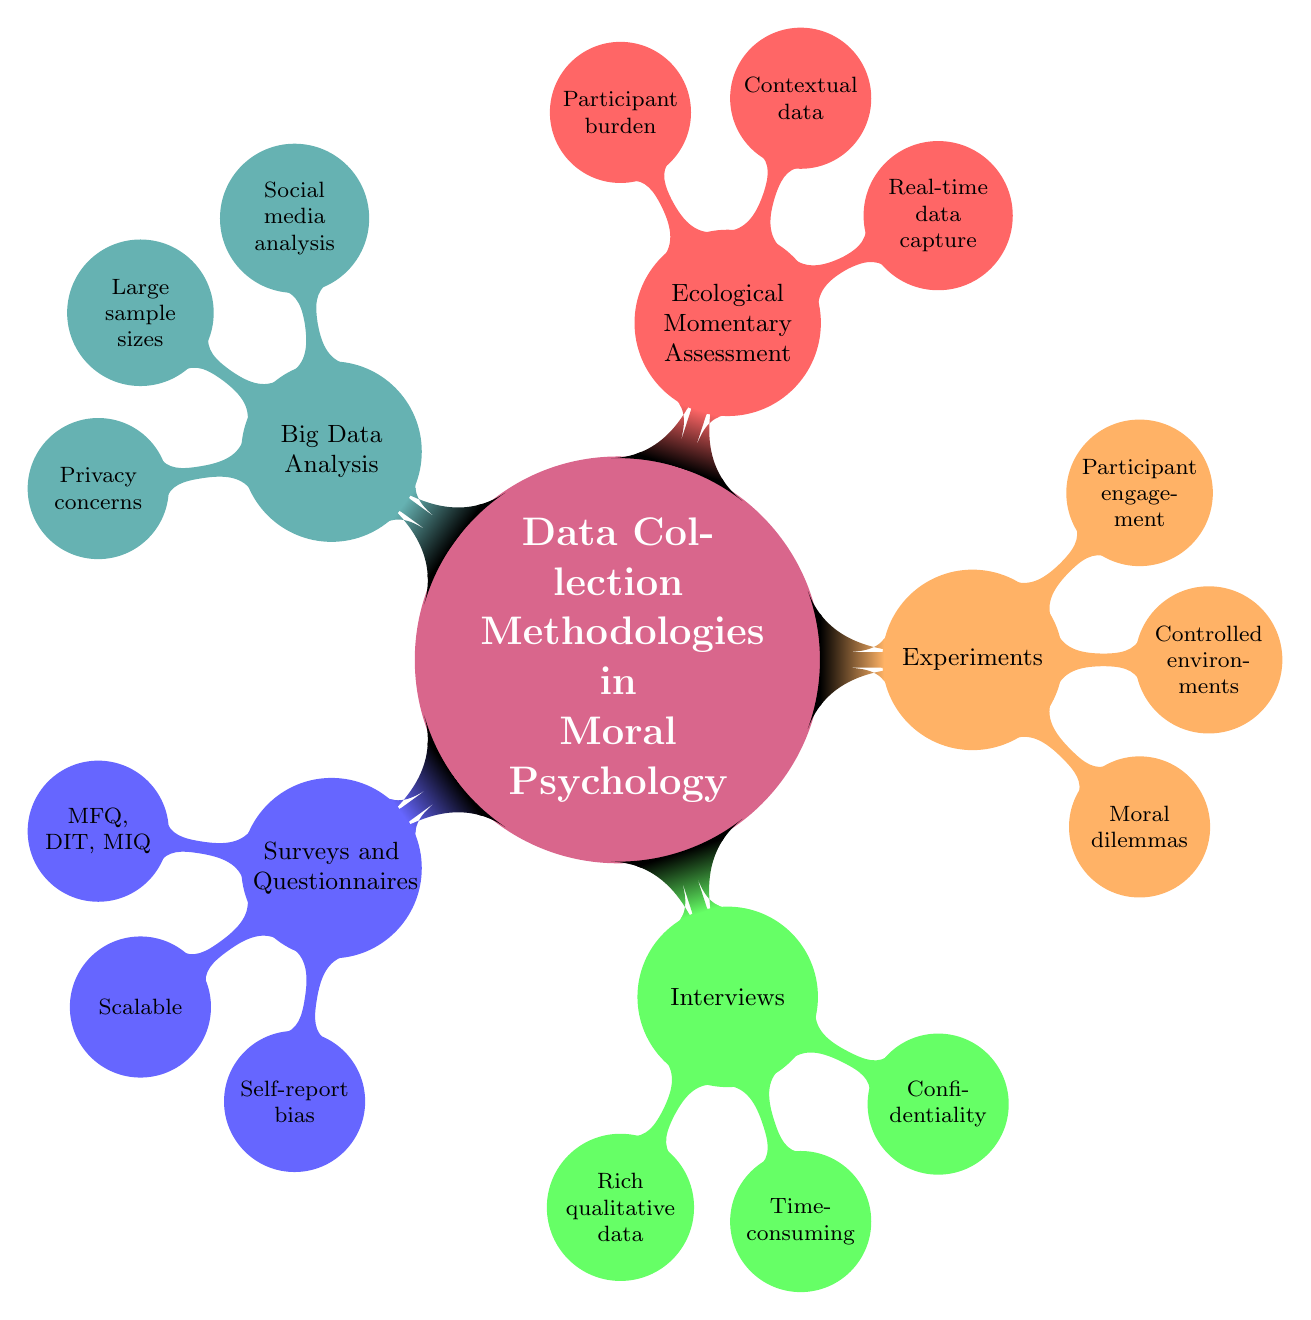What are the primary data collection methodologies in moral psychology? The diagram lists five primary methodologies: Surveys and Questionnaires, Interviews, Experiments, Ecological Momentary Assessment, and Big Data Analysis.
Answer: Surveys and Questionnaires, Interviews, Experiments, Ecological Momentary Assessment, Big Data Analysis Which methodology provides rich qualitative data? The Interviews node specifies "Rich qualitative data" as one of its advantages.
Answer: Interviews What is a challenge associated with surveys and questionnaires? The diagram under Surveys and Questionnaires lists “Self-report bias” as a challenge.
Answer: Self-report bias How many advantages are listed under the Big Data Analysis methodology? The Big Data Analysis node has three advantages identified in the diagram: "Large sample sizes," "Behavioral data," and “Privacy concerns.”
Answer: Three What participant experience aspect is associated with Ecological Momentary Assessment? The node under Ecological Momentary Assessment states “Frequent prompts” as a participant experience challenge.
Answer: Frequent prompts What is one ethical consideration mentioned in connection with experiments? The Experiments section notes "Ethical considerations" as a challenge.
Answer: Ethical considerations What is a common theme across the challenges listed for various methodologies? Many challenges are related to participant engagement, such as "Participant burden" under Ecological Momentary Assessment and "Self-report bias" under surveys. This indicates a theme of managing participant interaction and emotions.
Answer: Participant engagement Which methodology is described as time-consuming? The Interviews section explicitly states "Time-consuming" as a challenge associated with this methodology.
Answer: Interviews How many examples are provided under the Interviews node? The node lists two examples: "Semi-structured interviews" and "In-depth interviews," making the count two.
Answer: Two 